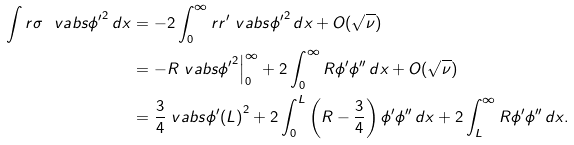<formula> <loc_0><loc_0><loc_500><loc_500>\int r \sigma \ v a b s { \phi ^ { \prime } } ^ { 2 } \, d x & = - 2 \int _ { 0 } ^ { \infty } r r ^ { \prime } \ v a b s { \phi ^ { \prime } } ^ { 2 } \, d x + O ( \sqrt { \nu } ) \\ & = - R \ v a b s { \phi ^ { \prime } } ^ { 2 } \Big | _ { 0 } ^ { \infty } + 2 \int _ { 0 } ^ { \infty } R \phi ^ { \prime } \phi ^ { \prime \prime } \, d x + O ( \sqrt { \nu } ) \\ & = \frac { 3 } { 4 } \ v a b s { \phi ^ { \prime } ( L ) } ^ { 2 } + 2 \int _ { 0 } ^ { L } \left ( R - \frac { 3 } { 4 } \right ) \phi ^ { \prime } \phi ^ { \prime \prime } \, d x + 2 \int _ { L } ^ { \infty } R \phi ^ { \prime } \phi ^ { \prime \prime } \, d x .</formula> 